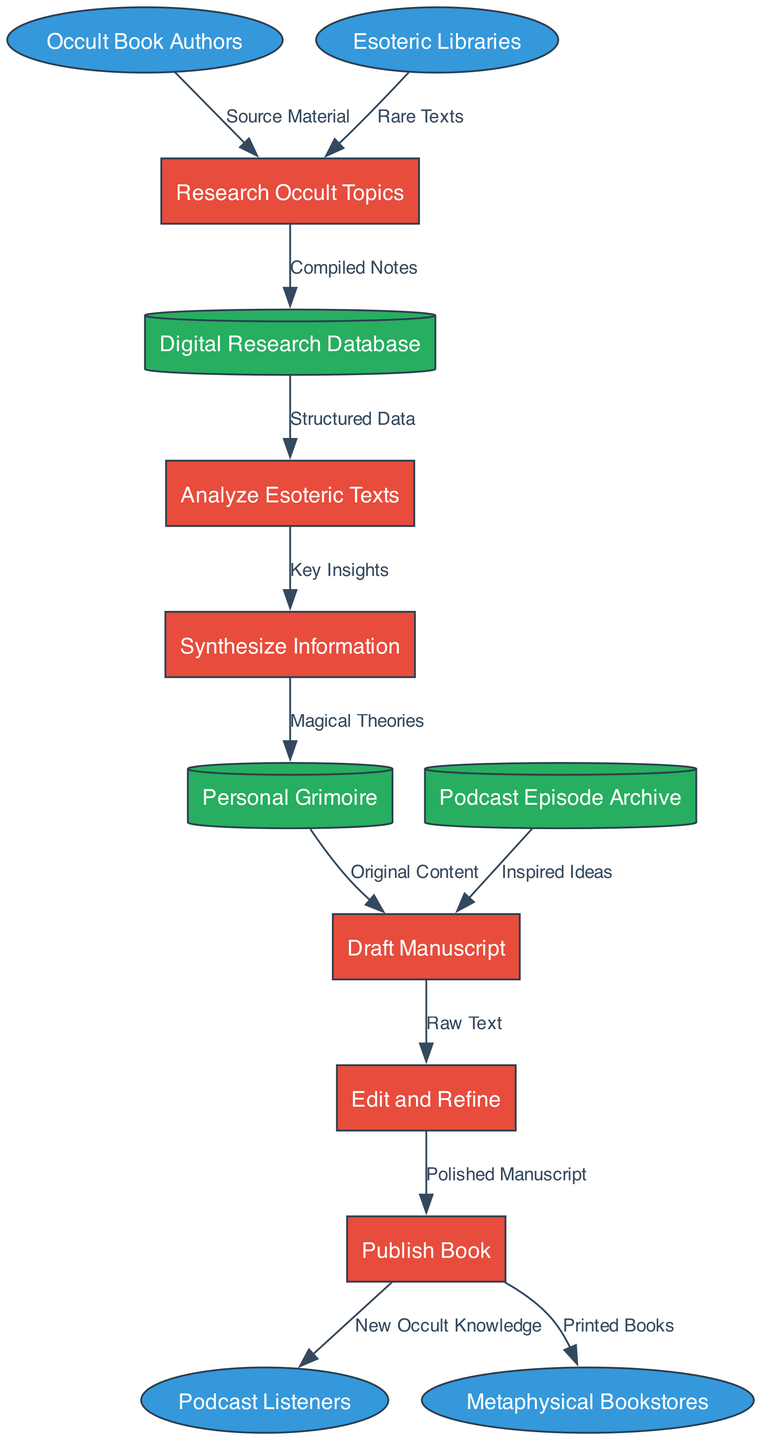What are the external entities in the diagram? The external entities include Occult Book Authors, Esoteric Libraries, Podcast Listeners, and Metaphysical Bookstores, which are represented as ellipses in the diagram.
Answer: Occult Book Authors, Esoteric Libraries, Podcast Listeners, Metaphysical Bookstores How many processes are listed in the diagram? There are six processes shown, which are Research Occult Topics, Analyze Esoteric Texts, Synthesize Information, Draft Manuscript, Edit and Refine, and Publish Book.
Answer: 6 What data flows from the Digital Research Database? From the Digital Research Database, the data flow labeled "Structured Data" goes to the Analyze Esoteric Texts process.
Answer: Structured Data Which data store receives "Magical Theories"? The Personal Grimoire receives the data flow labeled "Magical Theories" from the Synthesize Information process.
Answer: Personal Grimoire What is the final output of the Publish Book process? The Publish Book process outputs two flows: "New Occult Knowledge" to Podcast Listeners and "Printed Books" to Metaphysical Bookstores.
Answer: New Occult Knowledge, Printed Books How does Synthesize Information contribute to the writing process? The Synthesize Information process sends the flow labeled "Magical Theories" to the Personal Grimoire, which is then utilized as Original Content in the Draft Manuscript.
Answer: Magic Theories Which process follows Draft Manuscript? After Draft Manuscript, the process that follows is Edit and Refine, where the Raw Text is improved before publishing.
Answer: Edit and Refine What is the relationship between Esoteric Libraries and Research Occult Topics? Esoteric Libraries provide Rare Texts as a data flow labeled "Rare Texts" directly to the Research Occult Topics process, contributing to the authors' research.
Answer: Rare Texts How many data stores are present in the diagram? There are three data stores represented in the diagram: Personal Grimoire, Digital Research Database, and Podcast Episode Archive.
Answer: 3 